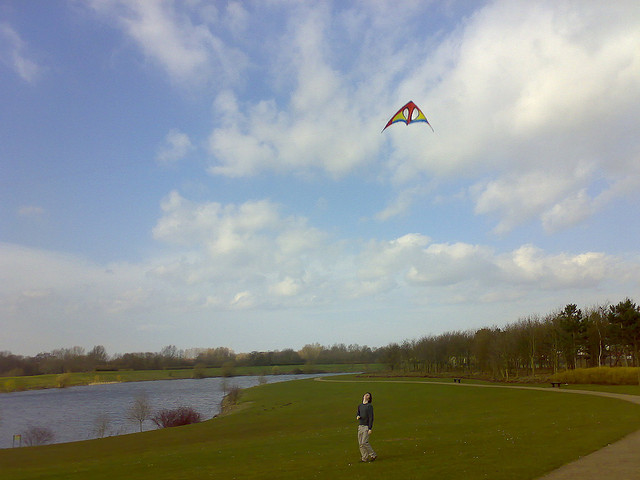What activity is the person in the image engaged in? The person in the image appears to be enjoying the outdoor activity of kite flying, with a vibrant kite soaring in the sky. 